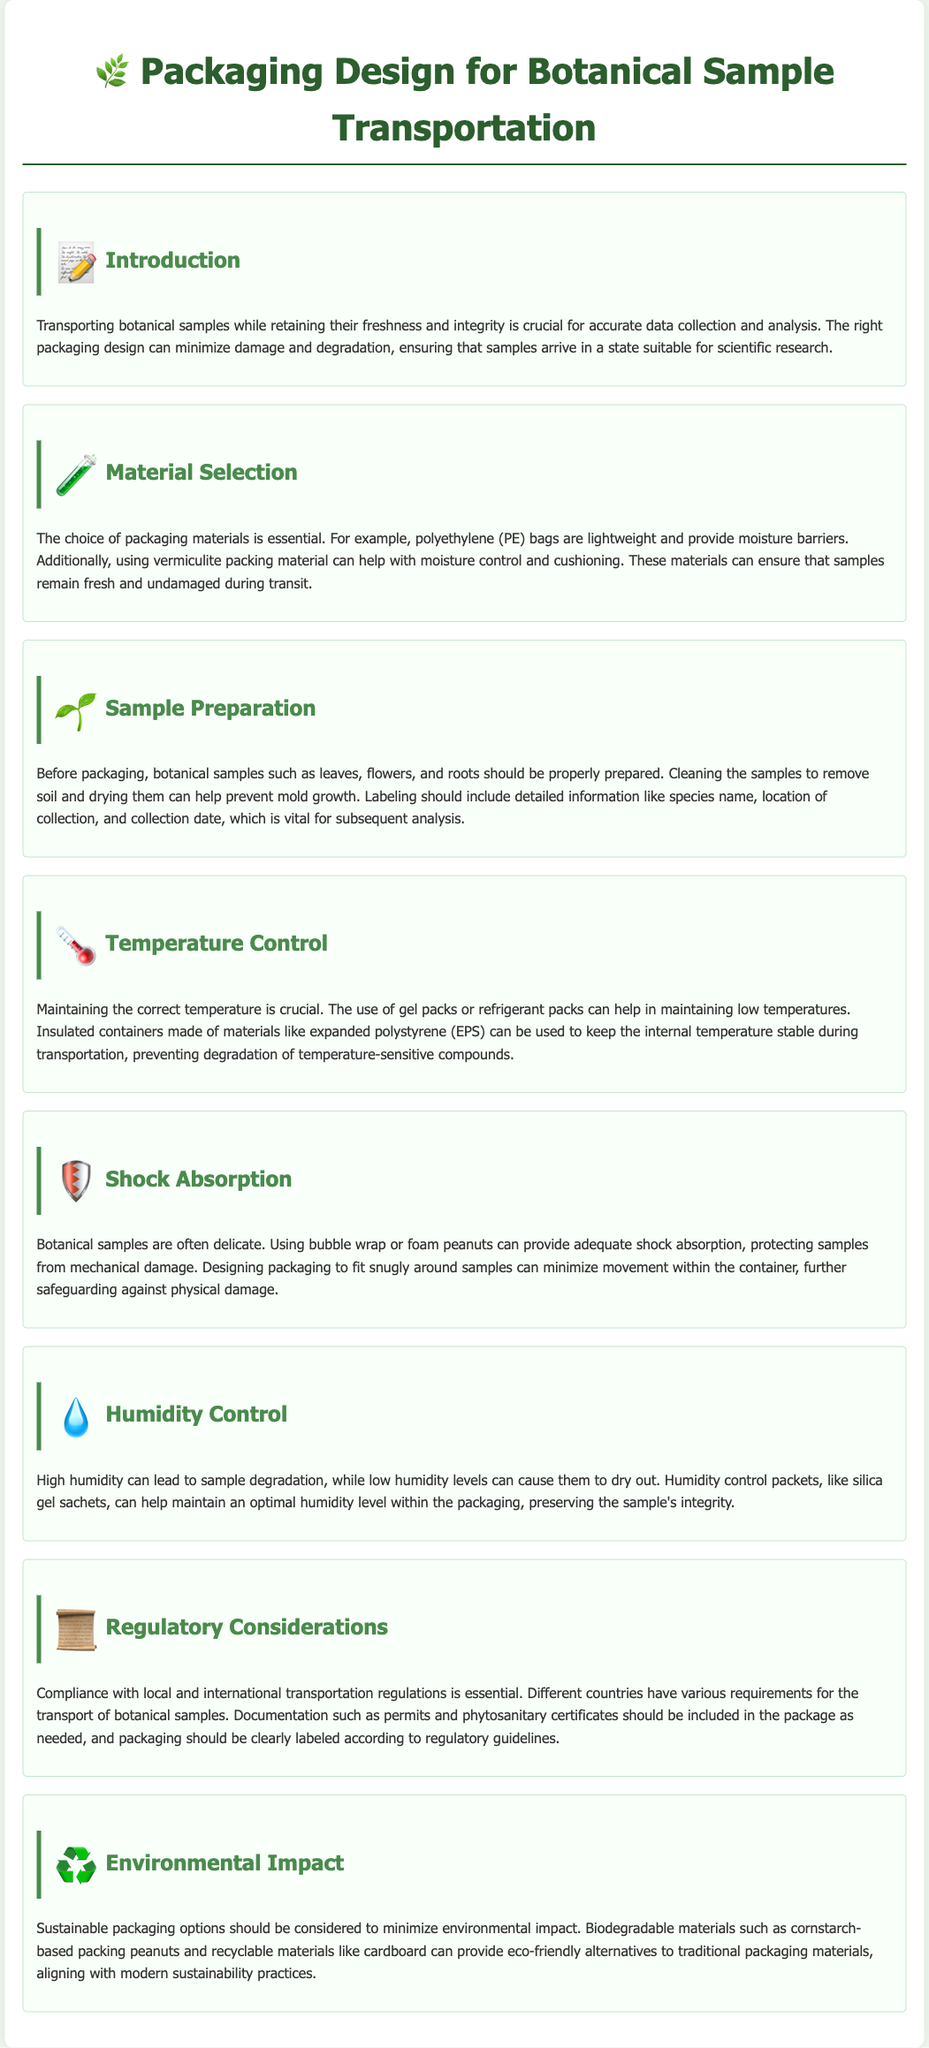What is the main purpose of the document? The document is designed to provide guidelines on packaging botanical samples for transportation while ensuring their freshness and integrity.
Answer: Guidelines for packaging botanical samples What material is recommended for moisture control? The document mentions vermiculite packing material as helpful for moisture control.
Answer: Vermiculite What should be included on the sample label? The label should include detailed information like species name, location of collection, and collection date.
Answer: Species name, location, collection date What type of container is suggested for maintaining temperature? Insulated containers made of materials like expanded polystyrene (EPS) are suggested to maintain temperature.
Answer: Expanded polystyrene (EPS) What is one recommended method for shock absorption? The document suggests using bubble wrap or foam peanuts to provide shock absorption.
Answer: Bubble wrap What is the importance of humidity control? Maintaining optimal humidity levels is crucial to prevent sample degradation or drying out.
Answer: Prevents degradation or drying out What is a sustainable alternative for packaging materials? Biodegradable materials such as cornstarch-based packing peanuts are suggested as eco-friendly options.
Answer: Cornstarch-based packing peanuts What type of documentation may be required for transportation? Permits and phytosanitary certificates should be included as necessary for transporting botanical samples.
Answer: Permits and phytosanitary certificates 